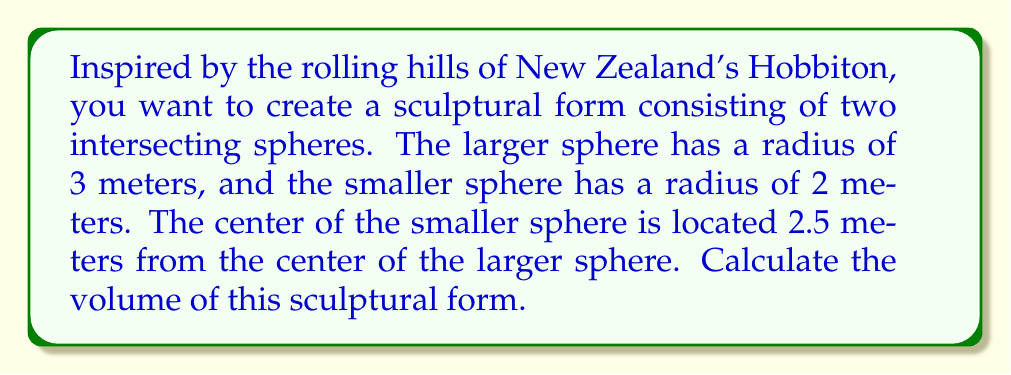Teach me how to tackle this problem. To solve this problem, we need to follow these steps:

1) First, let's recall the formula for the volume of a sphere:
   $$V_{sphere} = \frac{4}{3}\pi r^3$$

2) Calculate the volumes of both spheres:
   Larger sphere: $$V_1 = \frac{4}{3}\pi 3^3 = 36\pi$$ cubic meters
   Smaller sphere: $$V_2 = \frac{4}{3}\pi 2^3 = \frac{32}{3}\pi$$ cubic meters

3) Now, we need to calculate the volume of the intersection. The formula for the volume of intersection of two spheres is:

   $$V_{intersection} = \frac{\pi(R+r-d)^2(d^2+2dr-3r^2+2dR+6rR-3R^2)}{12d}$$

   Where R is the radius of the larger sphere, r is the radius of the smaller sphere, and d is the distance between their centers.

4) Plugging in our values:
   $$V_{intersection} = \frac{\pi(3+2-2.5)^2(2.5^2+2(2.5)(2)-3(2)^2+2(2.5)(3)+6(2)(3)-3(3)^2)}{12(2.5)}$$

5) Simplify:
   $$V_{intersection} = \frac{\pi(2.5)^2(6.25+10-12+15+36-27)}{30} = \frac{6.25\pi(28.25)}{30} = \frac{176.5625\pi}{30}$$

6) The total volume of the sculptural form is the sum of the volumes of both spheres minus the volume of their intersection:

   $$V_{total} = V_1 + V_2 - V_{intersection}$$
   $$V_{total} = 36\pi + \frac{32}{3}\pi - \frac{176.5625\pi}{30}$$

7) Simplify:
   $$V_{total} = \frac{1080\pi + 320\pi - 176.5625\pi}{30} = \frac{1223.4375\pi}{30}$$ cubic meters
Answer: $\frac{1223.4375\pi}{30}$ cubic meters 